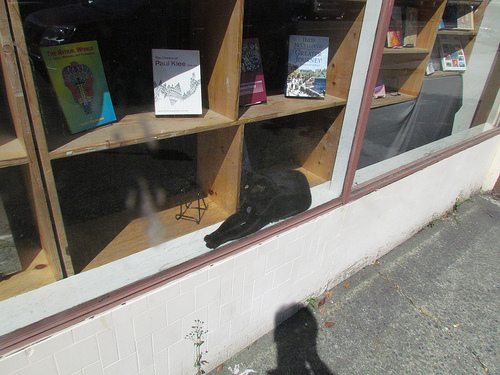<image>
Is there a cat to the left of the shadow? No. The cat is not to the left of the shadow. From this viewpoint, they have a different horizontal relationship. 